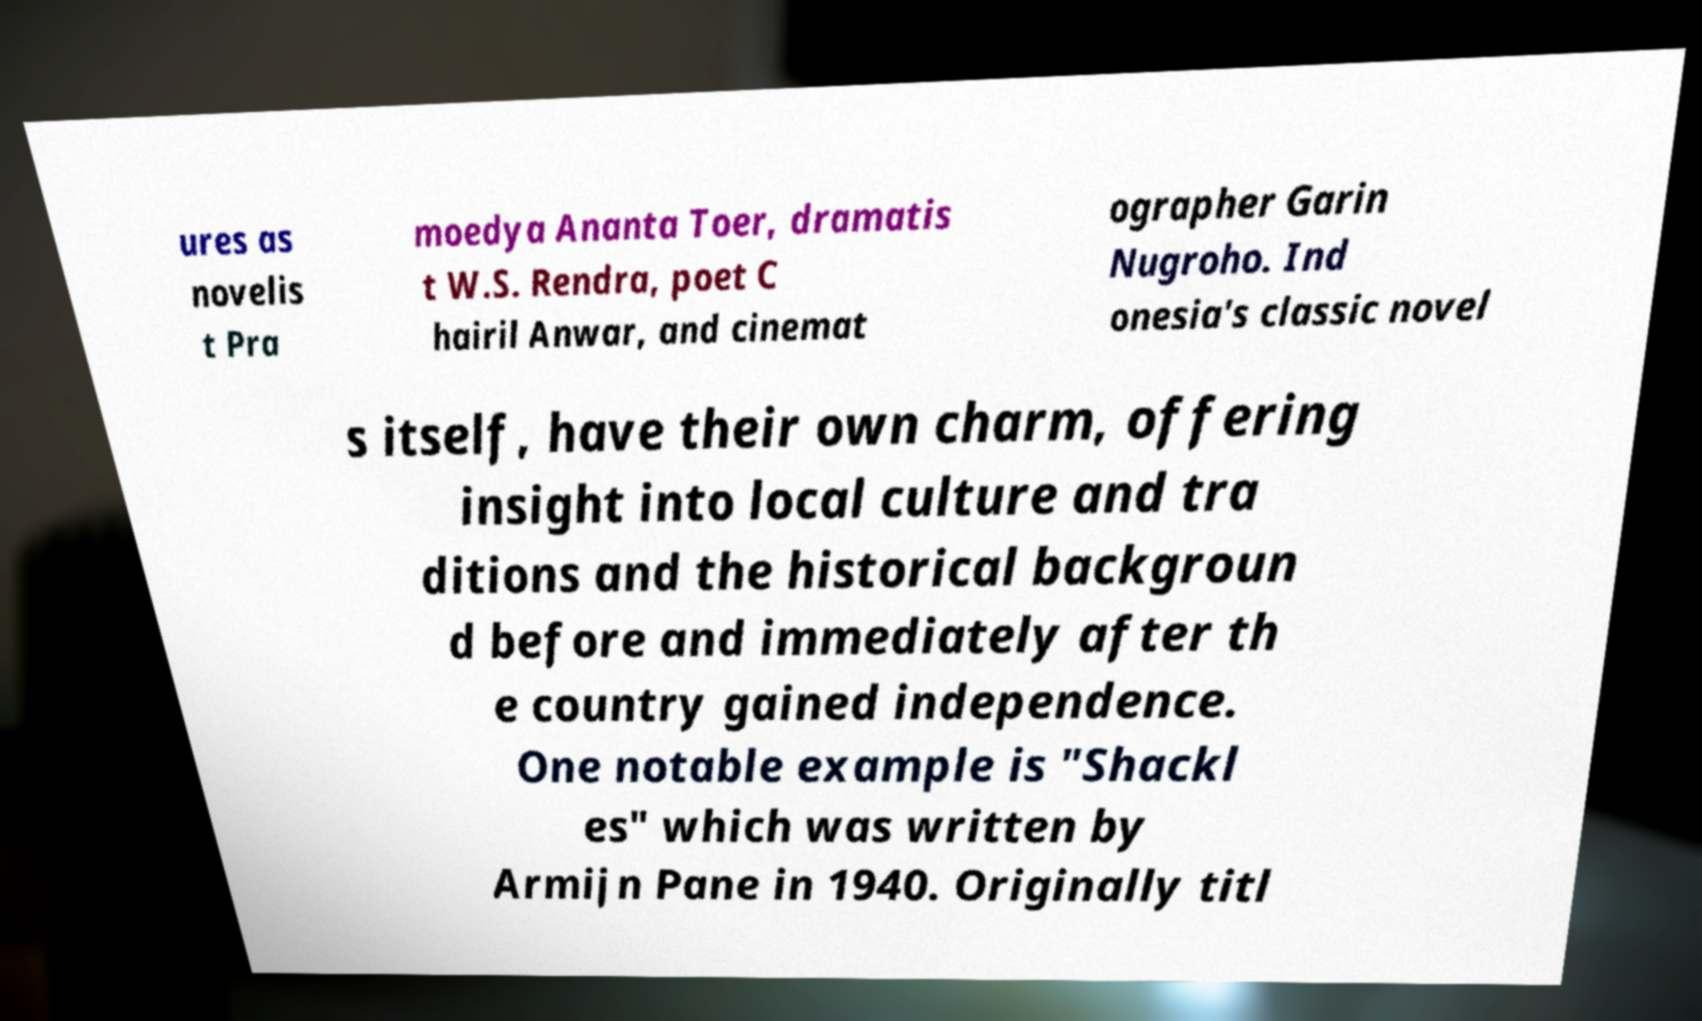Please read and relay the text visible in this image. What does it say? ures as novelis t Pra moedya Ananta Toer, dramatis t W.S. Rendra, poet C hairil Anwar, and cinemat ographer Garin Nugroho. Ind onesia's classic novel s itself, have their own charm, offering insight into local culture and tra ditions and the historical backgroun d before and immediately after th e country gained independence. One notable example is "Shackl es" which was written by Armijn Pane in 1940. Originally titl 